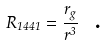Convert formula to latex. <formula><loc_0><loc_0><loc_500><loc_500>R _ { 1 4 4 1 } = \frac { r _ { g } } { r ^ { 3 } } \text { \ .}</formula> 